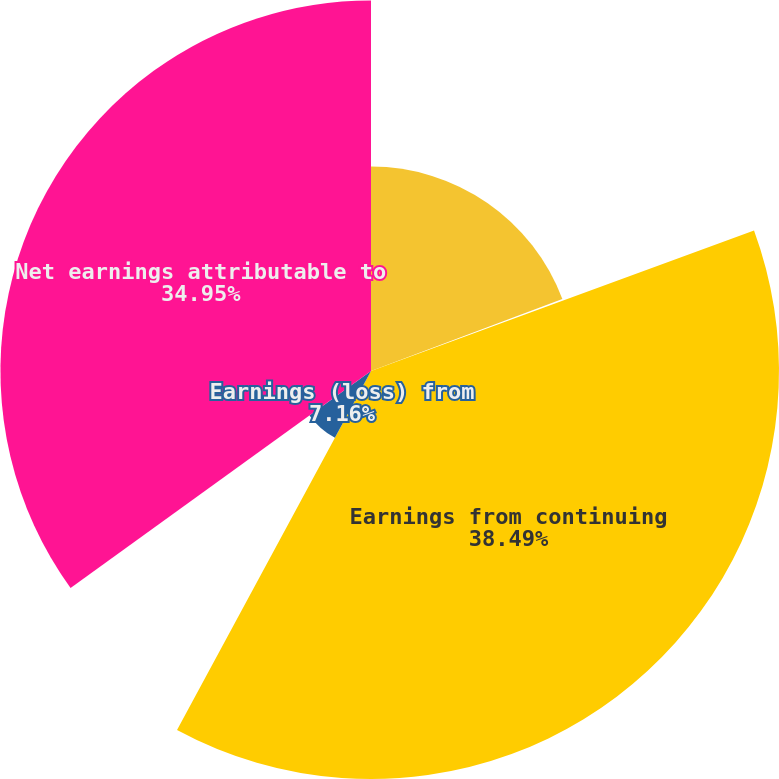Convert chart to OTSL. <chart><loc_0><loc_0><loc_500><loc_500><pie_chart><fcel>Weighted average shares -<fcel>Net earnings per share -<fcel>Earnings from continuing<fcel>Earnings (loss) from<fcel>Net earnings attributable to<nl><fcel>19.28%<fcel>0.12%<fcel>38.48%<fcel>7.16%<fcel>34.95%<nl></chart> 